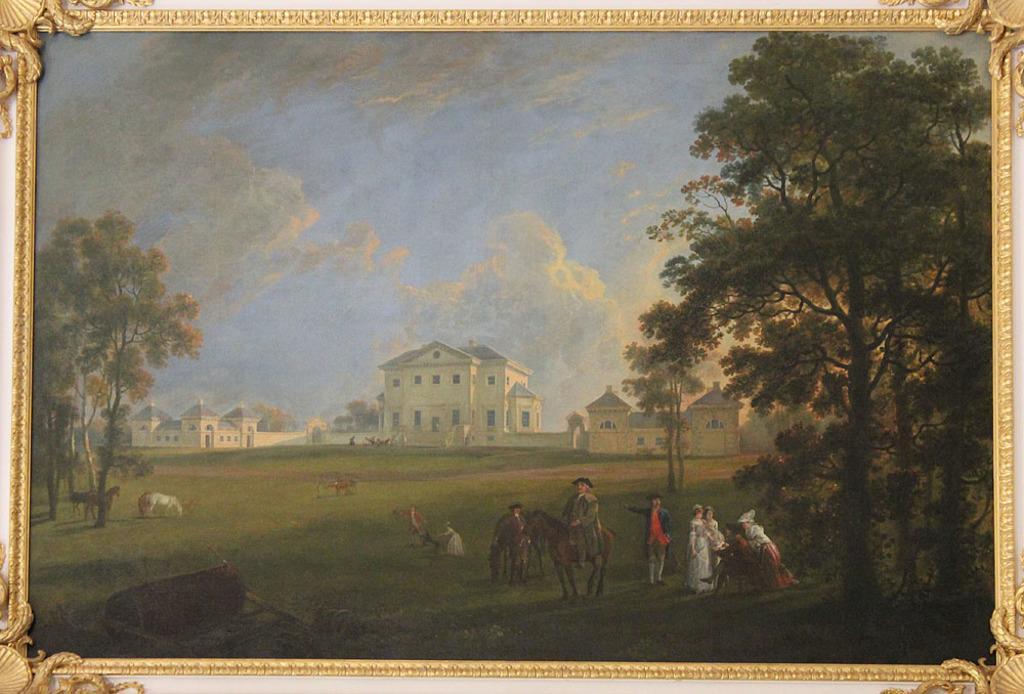Can you describe this image briefly? In this picture we can see a frame and in this frame we can see trees, buildings with windows, animals and some people on the grass and in the background we can see the sky with clouds. 